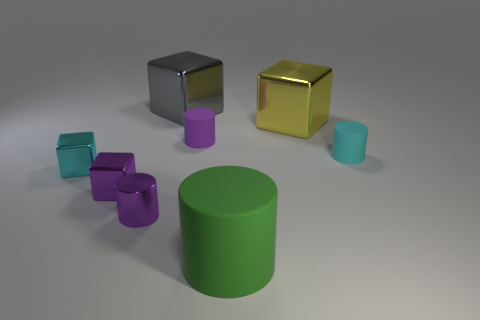Can you describe the lighting and shadows in the scene? The lighting in the scene is soft and diffused, creating gentle shadows that extend to the right of the objects. It appears to be a single light source coming from the left, as indicated by the direction of the shadows. The light gives the objects a slight gleam, particularly visible on the shiny surfaces of the metallic cubes. 